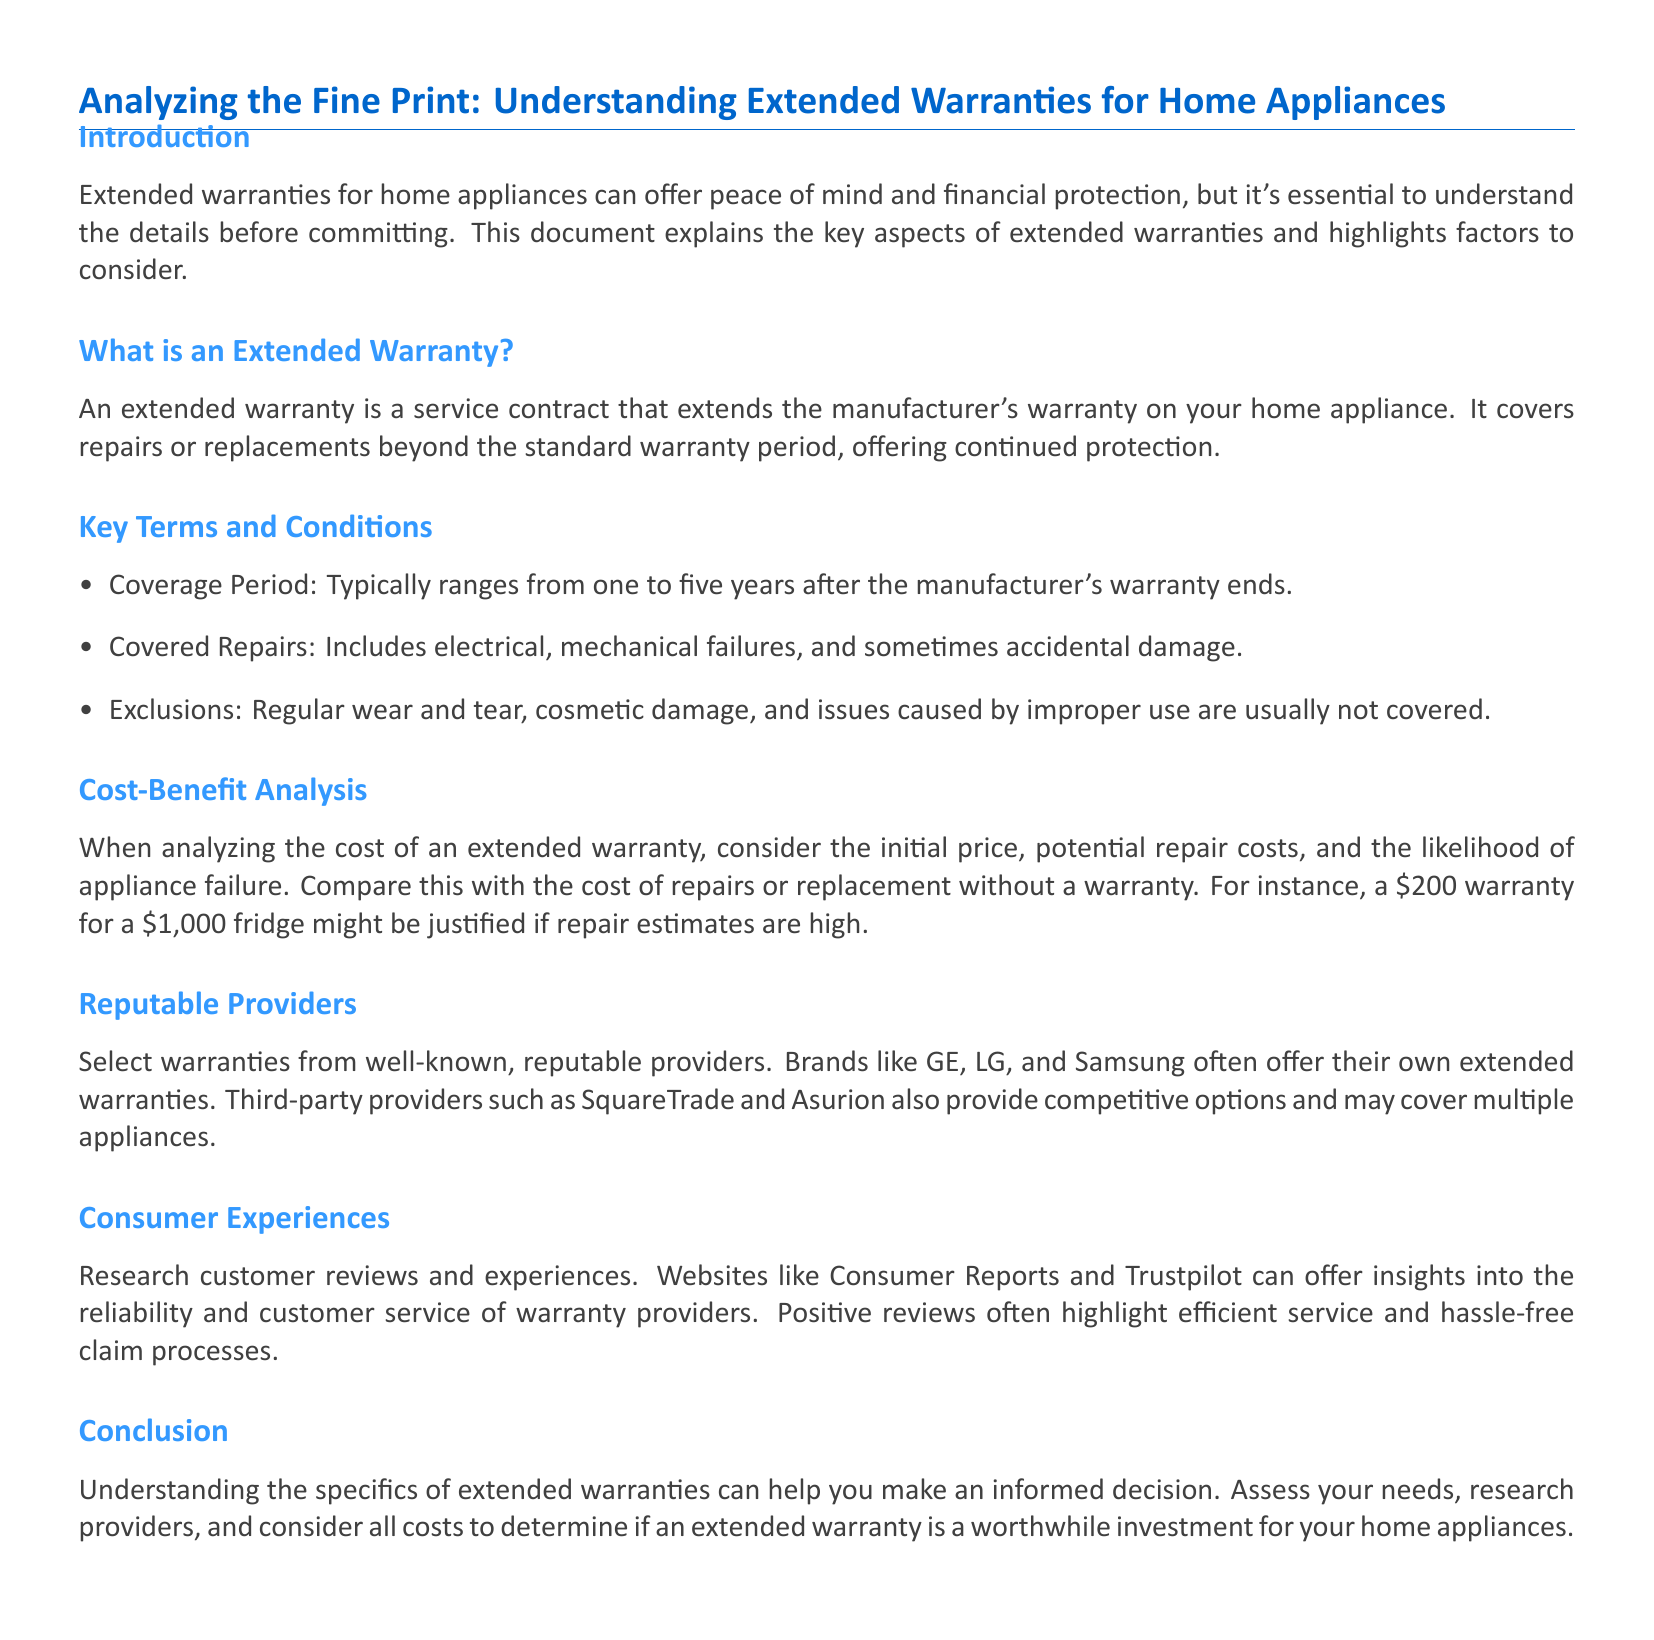What is an extended warranty? An extended warranty is a service contract that extends the manufacturer's warranty on your home appliance.
Answer: A service contract What is the coverage period of an extended warranty? The coverage period typically ranges from one to five years after the manufacturer's warranty ends.
Answer: One to five years What types of repairs are usually covered by extended warranties? Covered repairs include electrical, mechanical failures, and sometimes accidental damage.
Answer: Electrical and mechanical failures What are common exclusions in extended warranties? Regular wear and tear, cosmetic damage, and issues caused by improper use are usually not covered.
Answer: Regular wear and tear How much might a warranty for a $1,000 fridge typically cost? A $200 warranty for a $1,000 fridge might be justified if repair estimates are high.
Answer: $200 Which brands often offer their own extended warranties? Brands like GE, LG, and Samsung often offer their own extended warranties.
Answer: GE, LG, Samsung What can consumer reviews provide insights about? Consumer reviews can offer insights into the reliability and customer service of warranty providers.
Answer: Reliability and customer service Which websites are suggested for researching consumer experiences? Websites like Consumer Reports and Trustpilot can offer insights into warranty providers.
Answer: Consumer Reports and Trustpilot What should you research before selecting an extended warranty provider? Assess your needs, research providers, and consider all costs.
Answer: Your needs and providers 